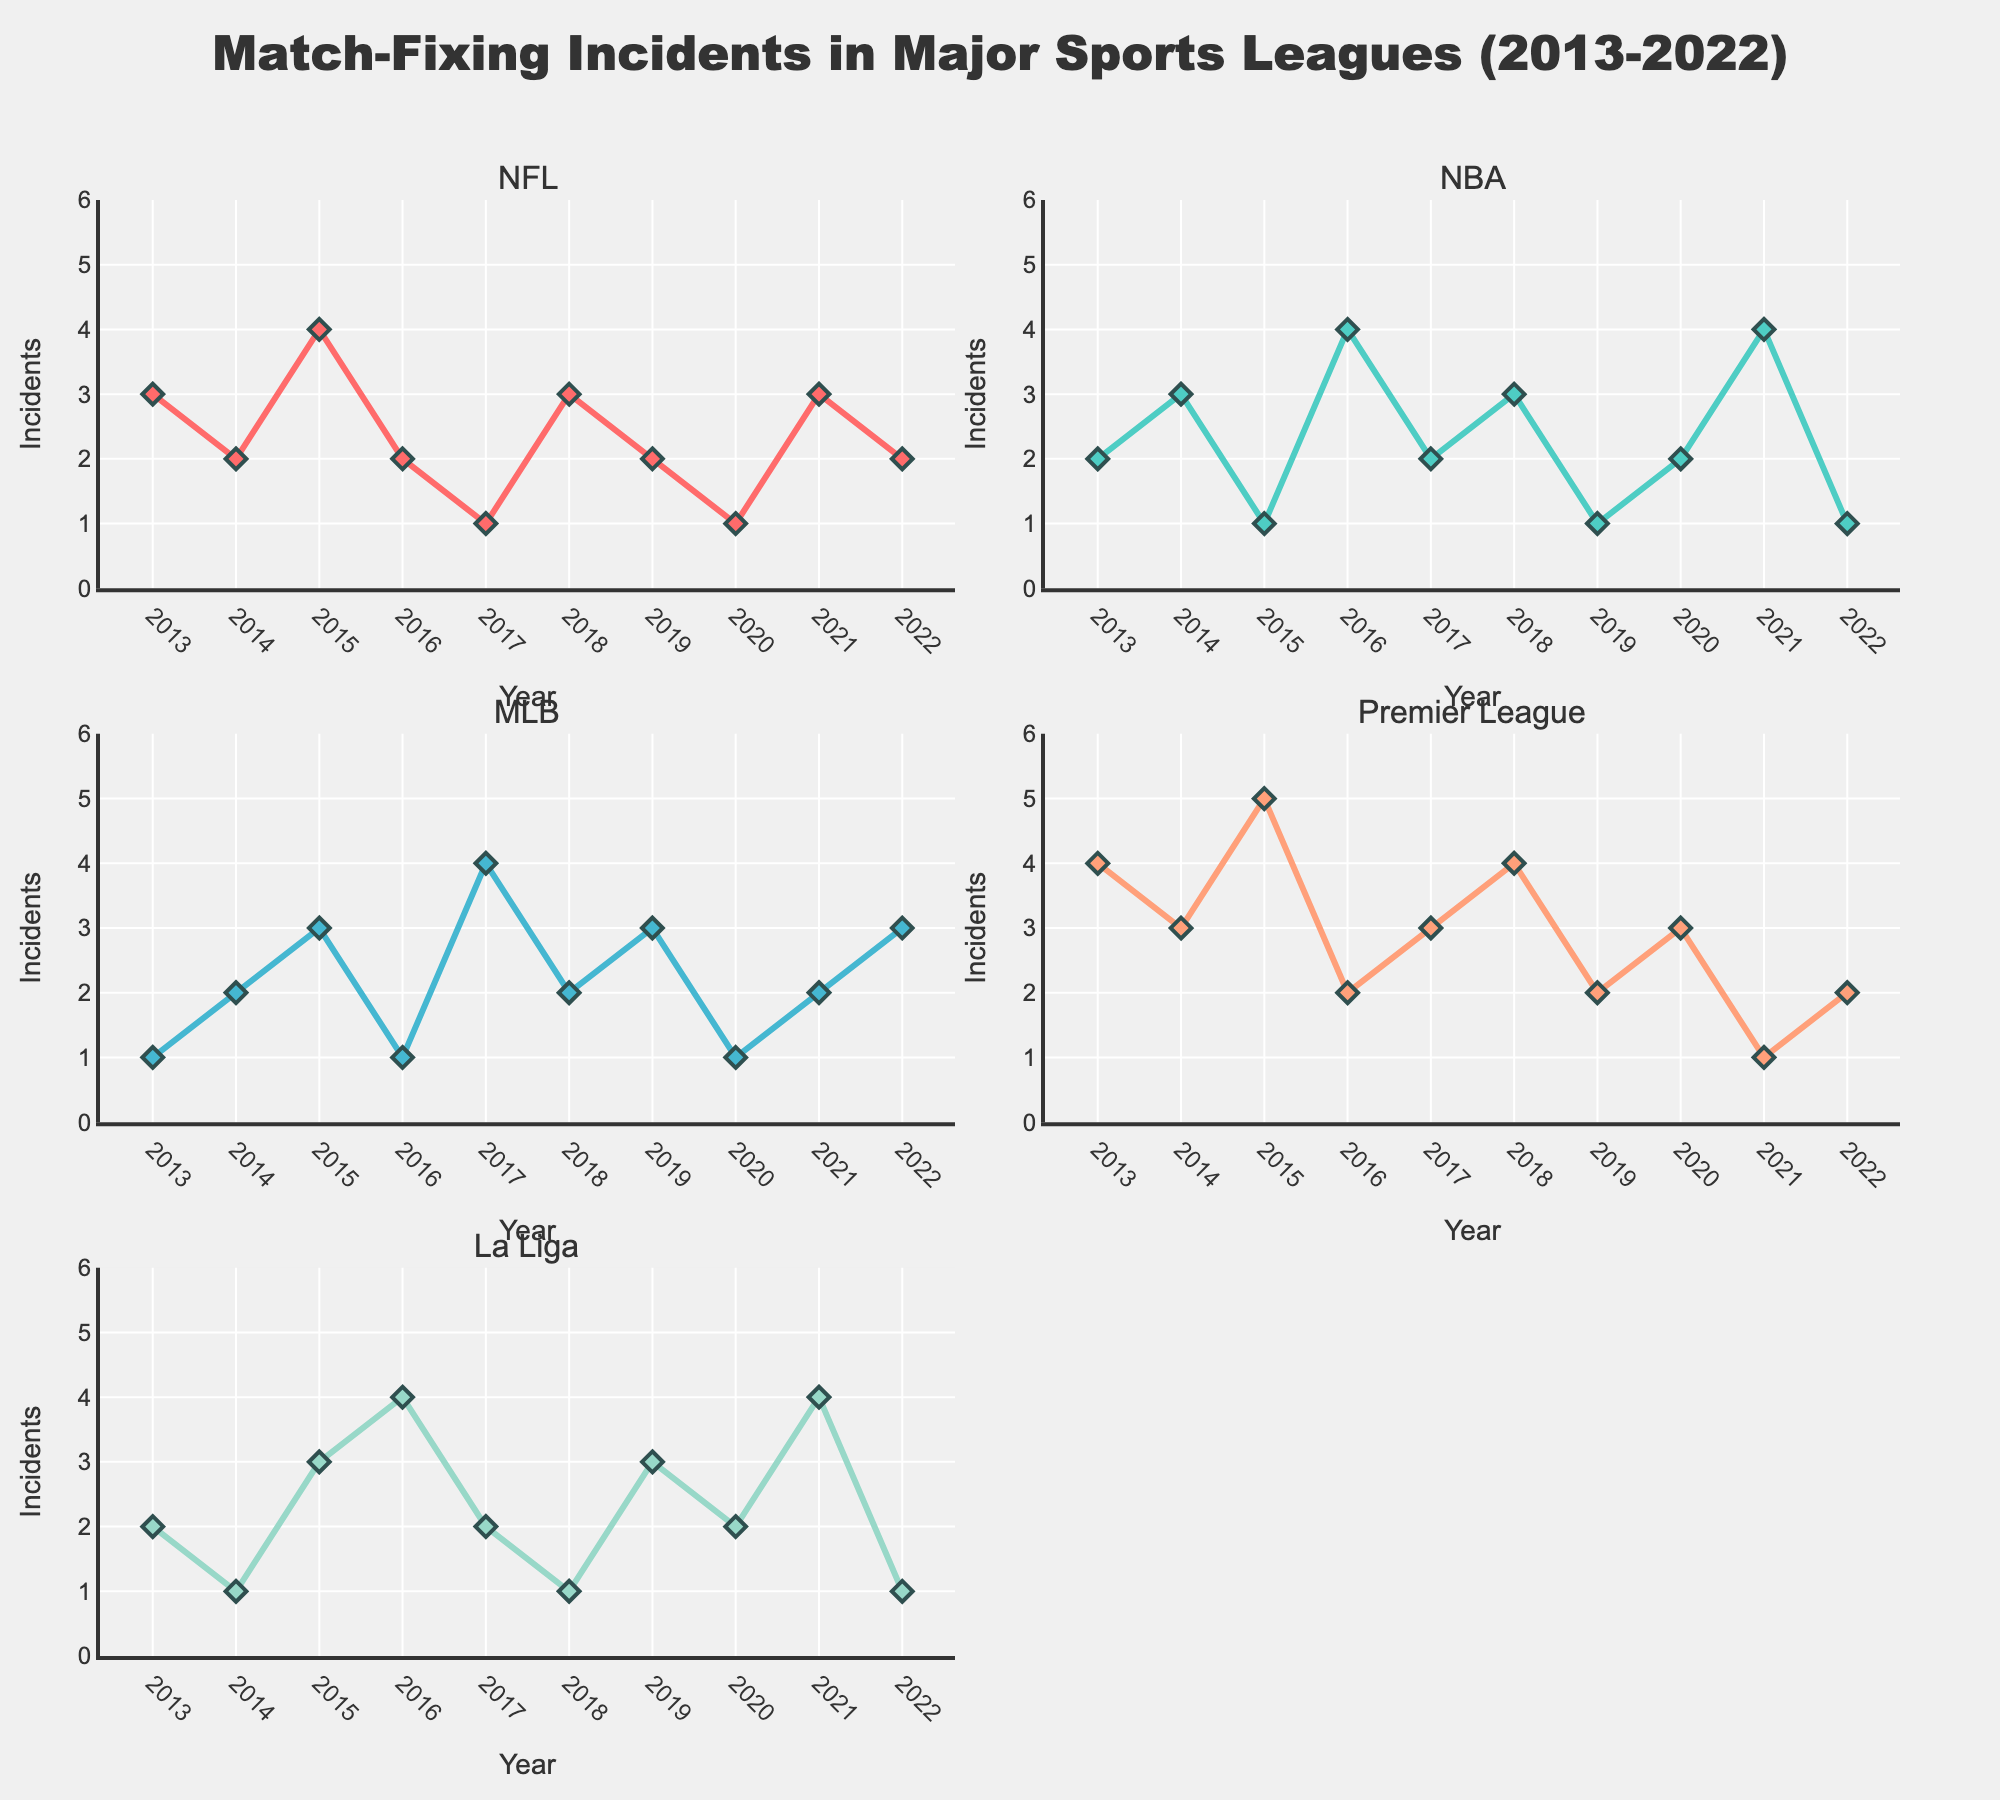How many players were part of the analysis? The scatter plot displays each player's transfer fee and age. We can count the number of data points representing the players on the chart.
Answer: 18 What is the average transfer fee for the players shown? To find the average transfer fee, sum all the displayed transfer fees and divide by the number of players. Total transfer fee = £95M + £70M + £57M + ... + £40M + £0M = £959M. Number of players = 18. Average transfer fee = £959M / 18 = £53.28M
Answer: £53.28M Who was the most expensive signing, and how old was he at the time? To find the most expensive signing, look for the highest transfer fee value on the scatter plot. The label with the highest point is "Paul Pogba" with a transfer fee of £105M at the age of 23.
Answer: Paul Pogba, 23 How many players were signed for a transfer fee of above £50M? To determine this, locate all the data points on the scatter plot where the transfer fee is above £50M and count them.
Answer: 9 Which player had the lowest transfer fee, and how much was it? On the scatter plot, look for the data point with the lowest transfer fee value. The lowest point is "Zlatan Ibrahimovic" with a transfer fee of £0M.
Answer: Zlatan Ibrahimovic, £0M Compare the transfer fees of Jadon Sancho and Aaron Wan-Bissaka. Who was more expensive and by how much? Identify the transfer fees of both players from the scatter plot. Jadon Sancho's transfer fee is £85M, and Aaron Wan-Bissaka's transfer fee is £55M. The difference is £85M - £55M = £30M.
Answer: Jadon Sancho, £30M How is the transfer fee distributed across different ages? To understand the distribution, observe the spread of transfer fees across different ages in the scatter plot. Assess the range and density of transfer fees for players of different ages.
Answer: Fees vary widely, with no clear age-fee trend What is the most common range of transfer fees? Refer to the box plot to find the interquartile range (IQR), which indicates the most common range. The IQR lies between the first quartile (Q1) and the third quartile (Q3) values.
Answer: £35M - £85M What can be observed about the relationship between player age and transfer fee? Analyze the scatter plot to identify any patterns or trends between player age and transfer fees. The plot shows that transfer fees do not consistently increase or decrease with age, indicating no strong correlation.
Answer: No strong correlation Who are the players signed at or above the age of 30, and what were their transfer fees? On the scatter plot, identify the data points for players aged 30 and above. They are "Casemiro" (age 30, £70M), "Cristiano Ronaldo" (age 36, £15M), and "Nemanja Matic" (age 29, £40M).
Answer: Casemiro: £70M, Cristiano Ronaldo: £15M, Nemanja Matic: £40M 